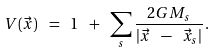Convert formula to latex. <formula><loc_0><loc_0><loc_500><loc_500>V ( \vec { x } ) \ = \ 1 \ + \ \sum _ { s } \frac { 2 G M _ { s } } { | \vec { x } \ - \ \vec { x } _ { s } | } \, .</formula> 